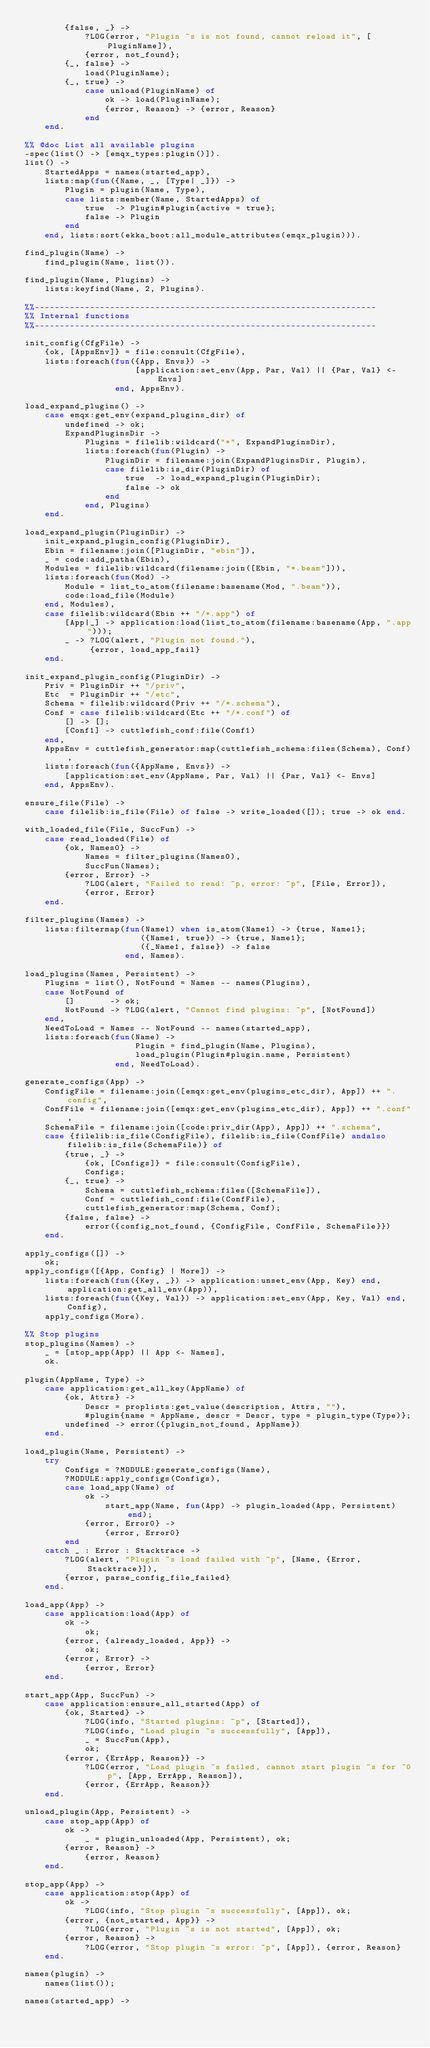Convert code to text. <code><loc_0><loc_0><loc_500><loc_500><_Erlang_>        {false, _} ->
            ?LOG(error, "Plugin ~s is not found, cannot reload it", [PluginName]),
            {error, not_found};
        {_, false} ->
            load(PluginName);
        {_, true} ->
            case unload(PluginName) of
                ok -> load(PluginName);
                {error, Reason} -> {error, Reason}
            end
    end.

%% @doc List all available plugins
-spec(list() -> [emqx_types:plugin()]).
list() ->
    StartedApps = names(started_app),
    lists:map(fun({Name, _, [Type| _]}) ->
        Plugin = plugin(Name, Type),
        case lists:member(Name, StartedApps) of
            true  -> Plugin#plugin{active = true};
            false -> Plugin
        end
    end, lists:sort(ekka_boot:all_module_attributes(emqx_plugin))).

find_plugin(Name) ->
    find_plugin(Name, list()).

find_plugin(Name, Plugins) ->
    lists:keyfind(Name, 2, Plugins).

%%--------------------------------------------------------------------
%% Internal functions
%%--------------------------------------------------------------------

init_config(CfgFile) ->
    {ok, [AppsEnv]} = file:consult(CfgFile),
    lists:foreach(fun({App, Envs}) ->
                      [application:set_env(App, Par, Val) || {Par, Val} <- Envs]
                  end, AppsEnv).

load_expand_plugins() ->
    case emqx:get_env(expand_plugins_dir) of
        undefined -> ok;
        ExpandPluginsDir ->
            Plugins = filelib:wildcard("*", ExpandPluginsDir),
            lists:foreach(fun(Plugin) ->
                PluginDir = filename:join(ExpandPluginsDir, Plugin),
                case filelib:is_dir(PluginDir) of
                    true  -> load_expand_plugin(PluginDir);
                    false -> ok
                end
            end, Plugins)
    end.

load_expand_plugin(PluginDir) ->
    init_expand_plugin_config(PluginDir),
    Ebin = filename:join([PluginDir, "ebin"]),
    _ = code:add_patha(Ebin),
    Modules = filelib:wildcard(filename:join([Ebin, "*.beam"])),
    lists:foreach(fun(Mod) ->
        Module = list_to_atom(filename:basename(Mod, ".beam")),
        code:load_file(Module)
    end, Modules),
    case filelib:wildcard(Ebin ++ "/*.app") of
        [App|_] -> application:load(list_to_atom(filename:basename(App, ".app")));
        _ -> ?LOG(alert, "Plugin not found."),
             {error, load_app_fail}
    end.

init_expand_plugin_config(PluginDir) ->
    Priv = PluginDir ++ "/priv",
    Etc  = PluginDir ++ "/etc",
    Schema = filelib:wildcard(Priv ++ "/*.schema"),
    Conf = case filelib:wildcard(Etc ++ "/*.conf") of
        [] -> [];
        [Conf1] -> cuttlefish_conf:file(Conf1)
    end,
    AppsEnv = cuttlefish_generator:map(cuttlefish_schema:files(Schema), Conf),
    lists:foreach(fun({AppName, Envs}) ->
        [application:set_env(AppName, Par, Val) || {Par, Val} <- Envs]
    end, AppsEnv).

ensure_file(File) ->
    case filelib:is_file(File) of false -> write_loaded([]); true -> ok end.

with_loaded_file(File, SuccFun) ->
    case read_loaded(File) of
        {ok, Names0} ->
            Names = filter_plugins(Names0),
            SuccFun(Names);
        {error, Error} ->
            ?LOG(alert, "Failed to read: ~p, error: ~p", [File, Error]),
            {error, Error}
    end.

filter_plugins(Names) ->
    lists:filtermap(fun(Name1) when is_atom(Name1) -> {true, Name1};
                       ({Name1, true}) -> {true, Name1};
                       ({_Name1, false}) -> false
                    end, Names).

load_plugins(Names, Persistent) ->
    Plugins = list(), NotFound = Names -- names(Plugins),
    case NotFound of
        []       -> ok;
        NotFound -> ?LOG(alert, "Cannot find plugins: ~p", [NotFound])
    end,
    NeedToLoad = Names -- NotFound -- names(started_app),
    lists:foreach(fun(Name) ->
                      Plugin = find_plugin(Name, Plugins),
                      load_plugin(Plugin#plugin.name, Persistent)
                  end, NeedToLoad).

generate_configs(App) ->
    ConfigFile = filename:join([emqx:get_env(plugins_etc_dir), App]) ++ ".config",
    ConfFile = filename:join([emqx:get_env(plugins_etc_dir), App]) ++ ".conf",
    SchemaFile = filename:join([code:priv_dir(App), App]) ++ ".schema",
    case {filelib:is_file(ConfigFile), filelib:is_file(ConfFile) andalso filelib:is_file(SchemaFile)} of
        {true, _} ->
            {ok, [Configs]} = file:consult(ConfigFile),
            Configs;
        {_, true} ->
            Schema = cuttlefish_schema:files([SchemaFile]),
            Conf = cuttlefish_conf:file(ConfFile),
            cuttlefish_generator:map(Schema, Conf);
        {false, false} ->
            error({config_not_found, {ConfigFile, ConfFile, SchemaFile}})
    end.

apply_configs([]) ->
    ok;
apply_configs([{App, Config} | More]) ->
    lists:foreach(fun({Key, _}) -> application:unset_env(App, Key) end, application:get_all_env(App)),
    lists:foreach(fun({Key, Val}) -> application:set_env(App, Key, Val) end, Config),
    apply_configs(More).

%% Stop plugins
stop_plugins(Names) ->
    _ = [stop_app(App) || App <- Names],
    ok.

plugin(AppName, Type) ->
    case application:get_all_key(AppName) of
        {ok, Attrs} ->
            Descr = proplists:get_value(description, Attrs, ""),
            #plugin{name = AppName, descr = Descr, type = plugin_type(Type)};
        undefined -> error({plugin_not_found, AppName})
    end.

load_plugin(Name, Persistent) ->
    try
        Configs = ?MODULE:generate_configs(Name),
        ?MODULE:apply_configs(Configs),
        case load_app(Name) of
            ok ->
                start_app(Name, fun(App) -> plugin_loaded(App, Persistent) end);
            {error, Error0} ->
                {error, Error0}
        end
    catch _ : Error : Stacktrace ->
        ?LOG(alert, "Plugin ~s load failed with ~p", [Name, {Error, Stacktrace}]),
        {error, parse_config_file_failed}
    end.

load_app(App) ->
    case application:load(App) of
        ok ->
            ok;
        {error, {already_loaded, App}} ->
            ok;
        {error, Error} ->
            {error, Error}
    end.

start_app(App, SuccFun) ->
    case application:ensure_all_started(App) of
        {ok, Started} ->
            ?LOG(info, "Started plugins: ~p", [Started]),
            ?LOG(info, "Load plugin ~s successfully", [App]),
            _ = SuccFun(App),
            ok;
        {error, {ErrApp, Reason}} ->
            ?LOG(error, "Load plugin ~s failed, cannot start plugin ~s for ~0p", [App, ErrApp, Reason]),
            {error, {ErrApp, Reason}}
    end.

unload_plugin(App, Persistent) ->
    case stop_app(App) of
        ok ->
            _ = plugin_unloaded(App, Persistent), ok;
        {error, Reason} ->
            {error, Reason}
    end.

stop_app(App) ->
    case application:stop(App) of
        ok ->
            ?LOG(info, "Stop plugin ~s successfully", [App]), ok;
        {error, {not_started, App}} ->
            ?LOG(error, "Plugin ~s is not started", [App]), ok;
        {error, Reason} ->
            ?LOG(error, "Stop plugin ~s error: ~p", [App]), {error, Reason}
    end.

names(plugin) ->
    names(list());

names(started_app) -></code> 